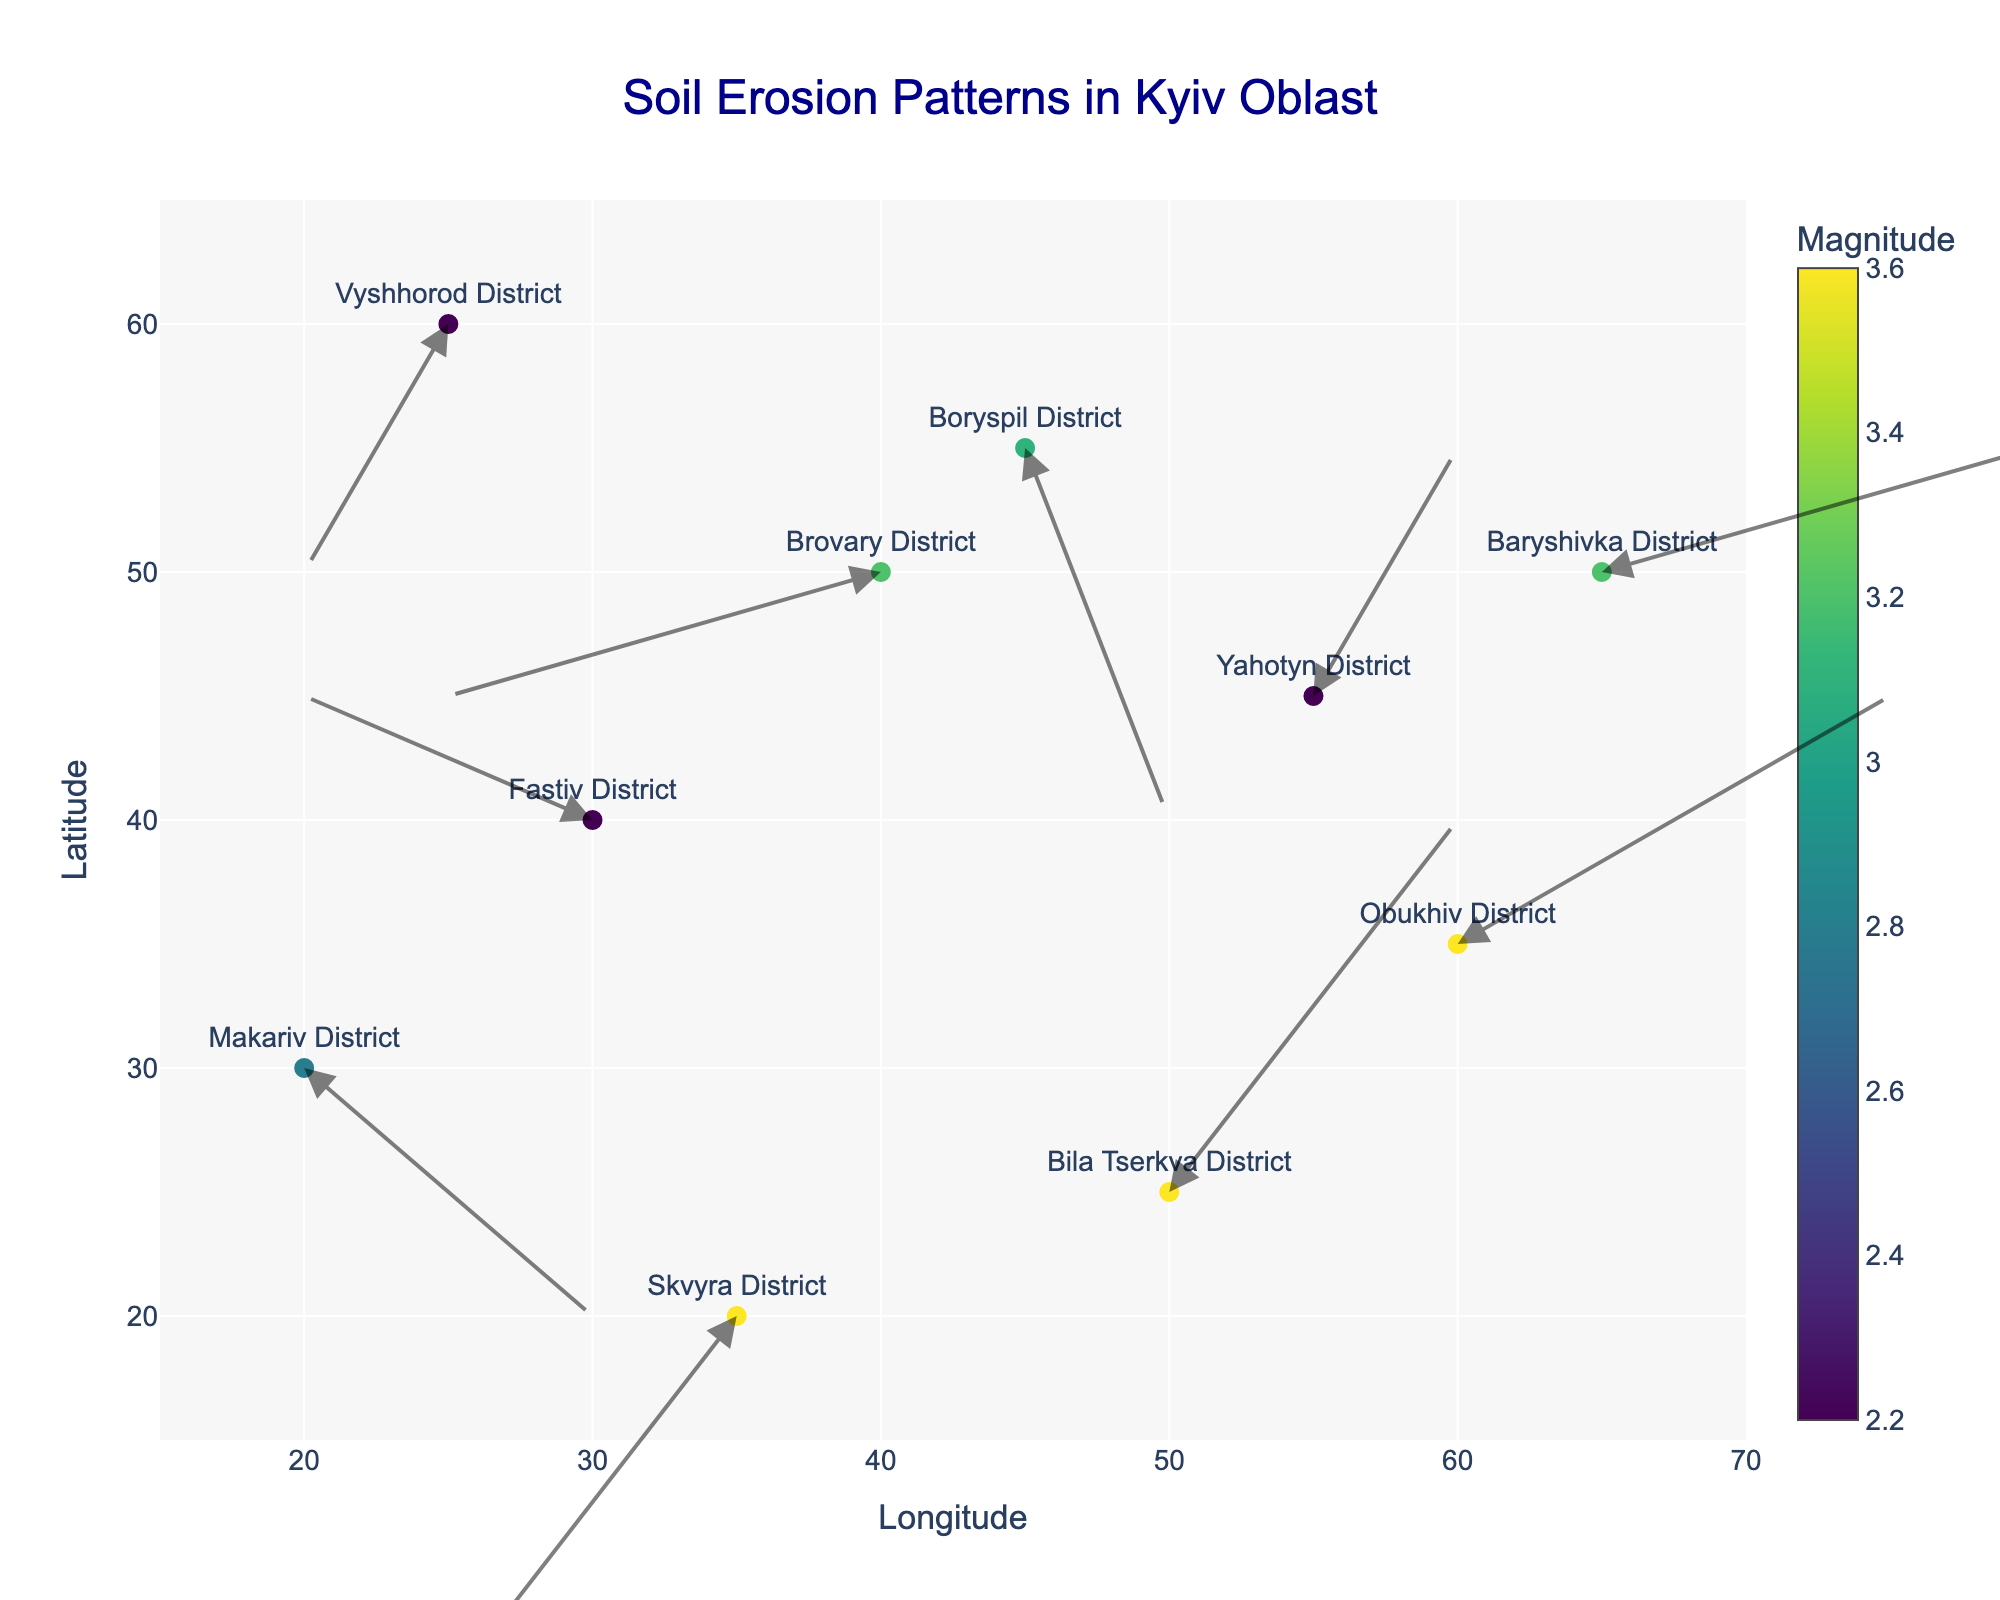What is the title of the quiver plot? The title of a plot is usually the text displayed prominently at the top. Reading the title of the plot directly from the figure tells us what the plot is about.
Answer: Soil Erosion Patterns in Kyiv Oblast How many agricultural areas are represented in the plot? Each point in the quiver plot represents a different agricultural area. By counting the number of points (or markers) in the plot, we can determine the number of areas. There are 10 markers each corresponding to Fastiv District, Boryspil District, Obukhiv District, Vyshhorod District, Bila Tserkva District, Brovary District, Yahotyn District, Makariv District, Skvyra District, and Baryshivka District.
Answer: 10 Which district shows the largest magnitude of soil erosion? To find this, we need to look at each point and its associated color, which represents the magnitude of soil erosion. The data with the largest associated magnitude value is 3.6. Both Obukhiv District and Skvyra District have a magnitude of 3.6, but we need only one answer for this question.
Answer: Obukhiv District In which direction is soil erosion heading in Brovary District? Brovary District’s data is at coordinates (40, 50) with an arrow indicating the direction. By looking at the direction of the arrow, we can see it points negatively along the x-axis and slightly negatively along the y-axis.
Answer: Southwest Compare the magnitudes of soil erosion in Bila Tserkva District and Skvyra District. Which one is higher? To answer this, check both the magnitudes for Bila Tserkva District and Skvyra District. Bila Tserkva District has a magnitude of 3.6 and Skvyra District also has a magnitude of 3.6.
Answer: They are equal How does soil erosion direction in Boryspil District compare to that in Makariv District? We need to compare the directions of soil erosion represented by the arrows. In Boryspil District, the arrow points south (x:1, y:-3), and in Makariv District, the arrow points northwest (x:2, y:-2). Observing the arrows reveals the directions quickly.
Answer: Boryspil District: South, Makariv District: Northwest What is the average magnitude of soil erosion across all districts? We calculate this by summing all the magnitude values and then dividing by the total number of districts. The sum of magnitudes is 30.9. Divide by 10 (number of districts), 30.9 / 10 = 3.09.
Answer: 3.09 What is the x-axis range of the plot? The range can be identified by looking at the minimum and maximum values of the x-axis displayed in the plot. It ranges from 15 to 70 based on the provided code.
Answer: 15 to 70 Which data point represents soil erosion moving in a northeast direction? A northeast direction implies positive x and positive y movements. Among the data points provided, Bila Tserkva District at (50, 25) with a vector (2, 3) represents a northeast direction.
Answer: Bila Tserkva District 